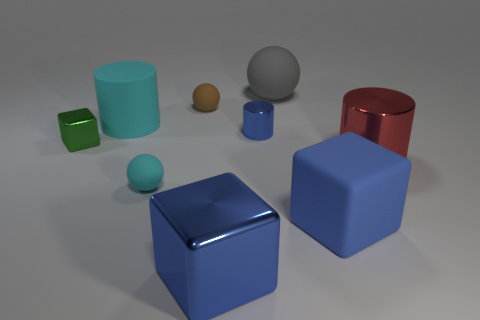Add 1 big cyan cylinders. How many objects exist? 10 Subtract all balls. How many objects are left? 6 Add 7 tiny blocks. How many tiny blocks exist? 8 Subtract 0 yellow cubes. How many objects are left? 9 Subtract all tiny cubes. Subtract all brown balls. How many objects are left? 7 Add 5 tiny cylinders. How many tiny cylinders are left? 6 